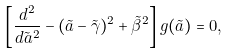<formula> <loc_0><loc_0><loc_500><loc_500>\left [ { \frac { d ^ { 2 } } { d { \tilde { a } } ^ { 2 } } } - ( \tilde { a } - { \tilde { \gamma } } ) ^ { 2 } + { \tilde { \beta } } ^ { 2 } \right ] g ( \tilde { a } ) = 0 ,</formula> 